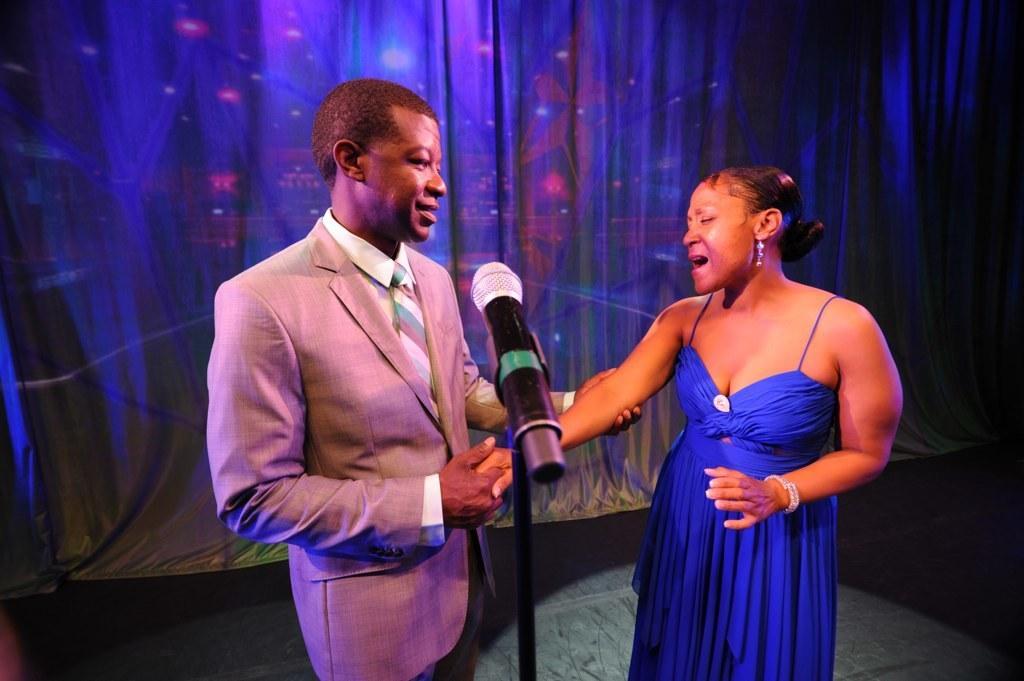Could you give a brief overview of what you see in this image? In this picture there is a person wearing suit is standing and holding a hand of a woman in front of him and there is a mic beside him and the background is in blue color. 